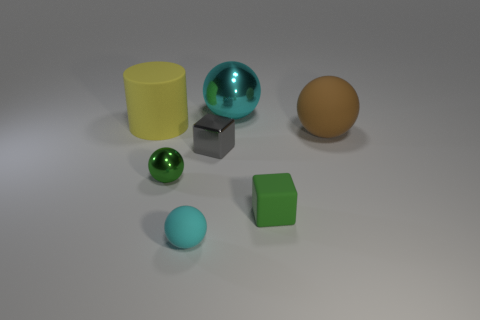The other tiny thing that is the same shape as the green matte object is what color? The other object that is the same spherical shape as the green ball is primarily gray with a slightly reflective surface, indicating it might be metallic in nature. 